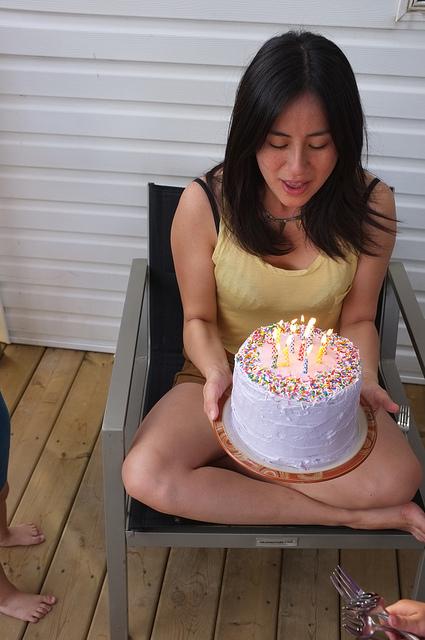Is the woman kneeling in the chair?
Quick response, please. No. What color is the woman's shirt?
Concise answer only. Yellow. What is the occasion for this woman getting a cake?
Be succinct. Birthday. 